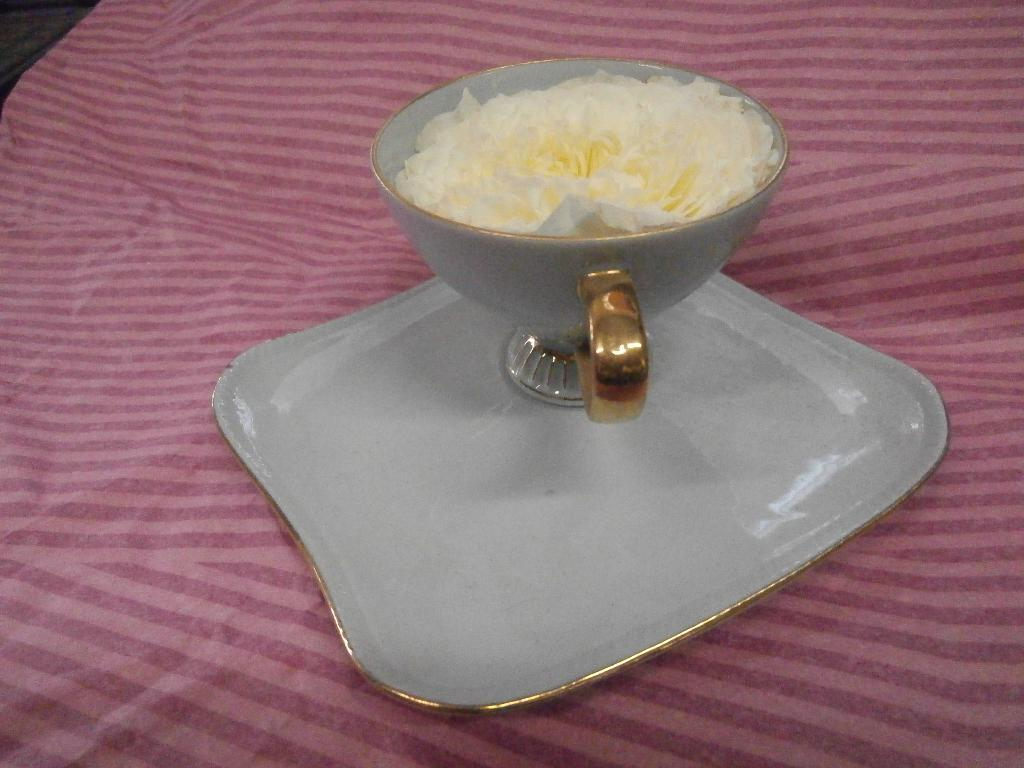What type of furniture is present in the image? There is a table in the image. What is covering the table? There is a cloth on the table. What objects are placed on the table? There is a plate and a cup on the table. What is inside the cup? The cup contains a white-colored flower. What type of match is being played on the table in the image? There is no match being played on the table in the image. The table has a cloth, plate, cup, and a white-colored flower inside the cup, but no game or match is present. 